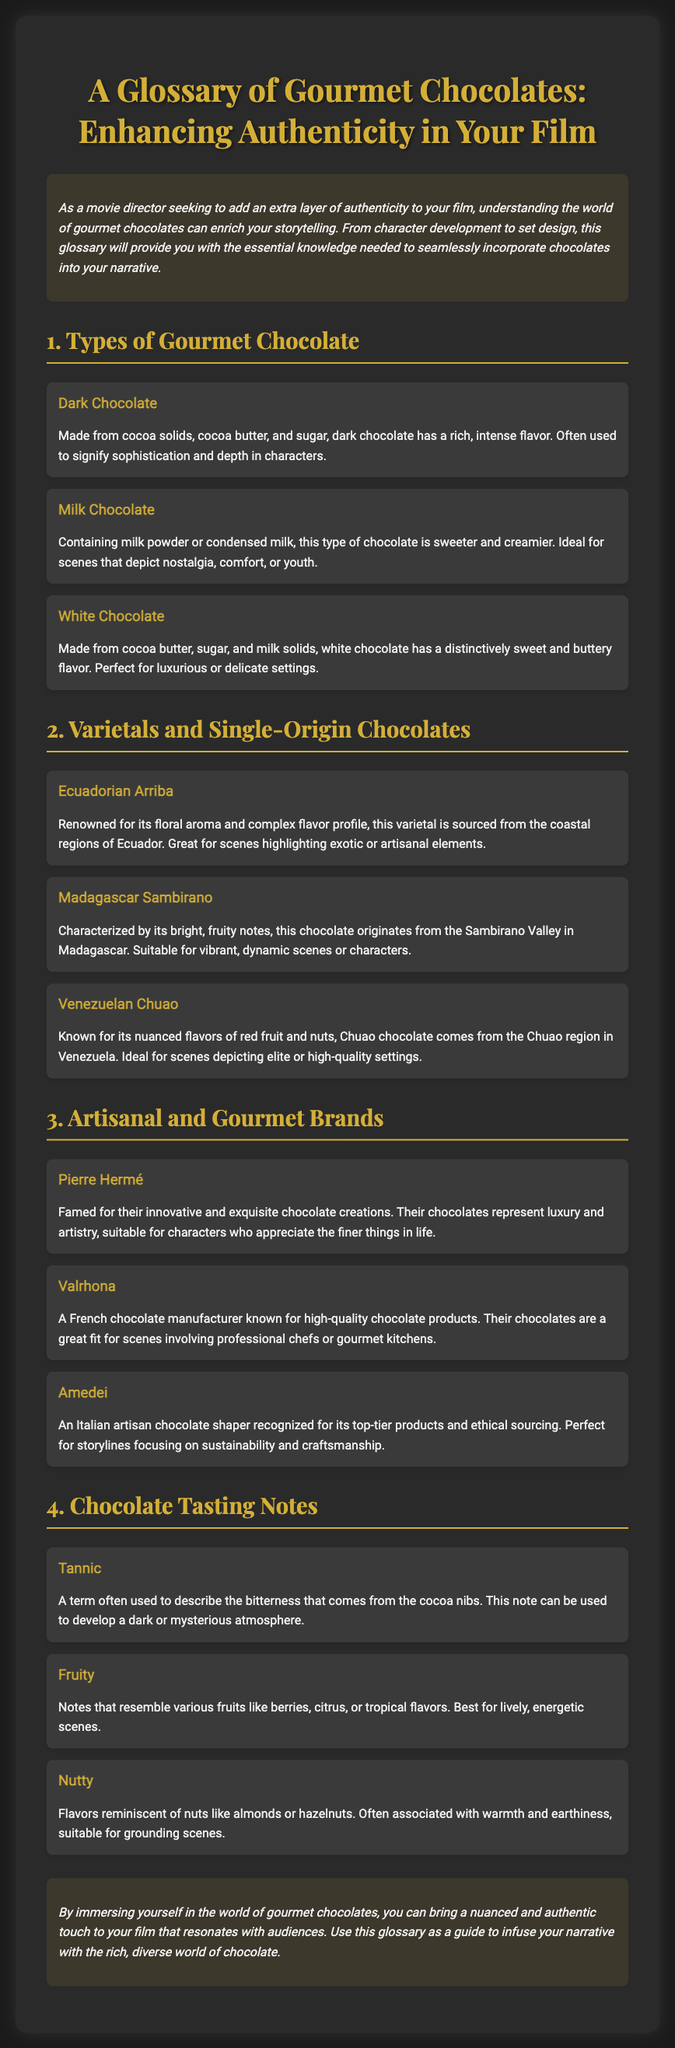what is the title of the flyer? The title of the flyer is prominently displayed at the top of the document, which introduces the topic of gourmet chocolates in film.
Answer: A Glossary of Gourmet Chocolates: Enhancing Authenticity in Your Film how many types of gourmet chocolate are listed? The document outlines a section specifically dedicated to types of gourmet chocolate, providing three distinct types.
Answer: Three what chocolate type is associated with nostalgia and comfort? The document states that milk chocolate is ideal for scenes that depict nostalgia, comfort, or youth.
Answer: Milk Chocolate which chocolatier is known for innovative creations? The flyer introduces a gourmet brand recognized for its exquisite chocolate creations and innovative artistry.
Answer: Pierre Hermé what flavor notes can develop a dark atmosphere? The document mentions tannic flavors can be used to create a dark or mysterious atmosphere in a film.
Answer: Tannic what varietal is recognized for its fruity notes? The chocolate from Madagascar Sambirano is highlighted for its bright, fruity notes, making it suitable for vibrant scenes.
Answer: Madagascar Sambirano which brand is suitable for professional chefs? Valrhona is noted in the document as a French chocolate manufacturer suitable for scenes involving professional chefs.
Answer: Valrhona which type of chocolate is made from cocoa butter? The glossary lists white chocolate as being made from cocoa butter, sugar, and milk solids.
Answer: White Chocolate 